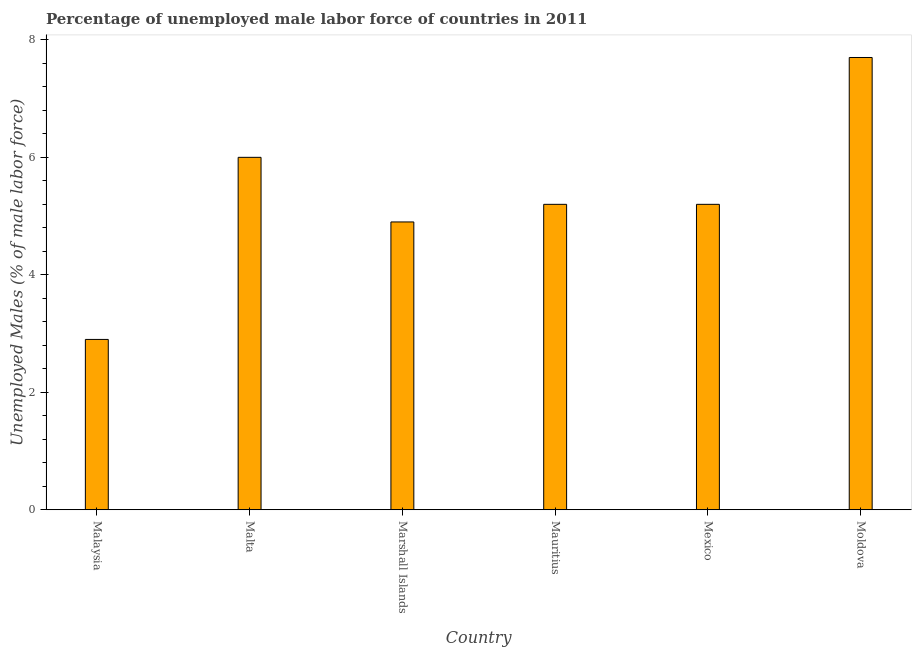Does the graph contain any zero values?
Offer a very short reply. No. What is the title of the graph?
Provide a succinct answer. Percentage of unemployed male labor force of countries in 2011. What is the label or title of the X-axis?
Provide a succinct answer. Country. What is the label or title of the Y-axis?
Offer a very short reply. Unemployed Males (% of male labor force). What is the total unemployed male labour force in Mexico?
Make the answer very short. 5.2. Across all countries, what is the maximum total unemployed male labour force?
Your answer should be very brief. 7.7. Across all countries, what is the minimum total unemployed male labour force?
Give a very brief answer. 2.9. In which country was the total unemployed male labour force maximum?
Offer a terse response. Moldova. In which country was the total unemployed male labour force minimum?
Keep it short and to the point. Malaysia. What is the sum of the total unemployed male labour force?
Offer a very short reply. 31.9. What is the average total unemployed male labour force per country?
Your answer should be compact. 5.32. What is the median total unemployed male labour force?
Keep it short and to the point. 5.2. What is the ratio of the total unemployed male labour force in Mauritius to that in Moldova?
Provide a short and direct response. 0.68. What is the difference between the highest and the lowest total unemployed male labour force?
Provide a short and direct response. 4.8. In how many countries, is the total unemployed male labour force greater than the average total unemployed male labour force taken over all countries?
Your response must be concise. 2. Are the values on the major ticks of Y-axis written in scientific E-notation?
Give a very brief answer. No. What is the Unemployed Males (% of male labor force) of Malaysia?
Give a very brief answer. 2.9. What is the Unemployed Males (% of male labor force) in Malta?
Make the answer very short. 6. What is the Unemployed Males (% of male labor force) in Marshall Islands?
Your response must be concise. 4.9. What is the Unemployed Males (% of male labor force) in Mauritius?
Give a very brief answer. 5.2. What is the Unemployed Males (% of male labor force) in Mexico?
Give a very brief answer. 5.2. What is the Unemployed Males (% of male labor force) in Moldova?
Ensure brevity in your answer.  7.7. What is the difference between the Unemployed Males (% of male labor force) in Malaysia and Malta?
Your answer should be very brief. -3.1. What is the difference between the Unemployed Males (% of male labor force) in Malaysia and Marshall Islands?
Make the answer very short. -2. What is the difference between the Unemployed Males (% of male labor force) in Malta and Mexico?
Ensure brevity in your answer.  0.8. What is the difference between the Unemployed Males (% of male labor force) in Malta and Moldova?
Your answer should be very brief. -1.7. What is the difference between the Unemployed Males (% of male labor force) in Marshall Islands and Mexico?
Make the answer very short. -0.3. What is the ratio of the Unemployed Males (% of male labor force) in Malaysia to that in Malta?
Make the answer very short. 0.48. What is the ratio of the Unemployed Males (% of male labor force) in Malaysia to that in Marshall Islands?
Your answer should be very brief. 0.59. What is the ratio of the Unemployed Males (% of male labor force) in Malaysia to that in Mauritius?
Keep it short and to the point. 0.56. What is the ratio of the Unemployed Males (% of male labor force) in Malaysia to that in Mexico?
Your answer should be compact. 0.56. What is the ratio of the Unemployed Males (% of male labor force) in Malaysia to that in Moldova?
Your answer should be compact. 0.38. What is the ratio of the Unemployed Males (% of male labor force) in Malta to that in Marshall Islands?
Your answer should be compact. 1.22. What is the ratio of the Unemployed Males (% of male labor force) in Malta to that in Mauritius?
Make the answer very short. 1.15. What is the ratio of the Unemployed Males (% of male labor force) in Malta to that in Mexico?
Your answer should be compact. 1.15. What is the ratio of the Unemployed Males (% of male labor force) in Malta to that in Moldova?
Your answer should be compact. 0.78. What is the ratio of the Unemployed Males (% of male labor force) in Marshall Islands to that in Mauritius?
Make the answer very short. 0.94. What is the ratio of the Unemployed Males (% of male labor force) in Marshall Islands to that in Mexico?
Make the answer very short. 0.94. What is the ratio of the Unemployed Males (% of male labor force) in Marshall Islands to that in Moldova?
Provide a short and direct response. 0.64. What is the ratio of the Unemployed Males (% of male labor force) in Mauritius to that in Moldova?
Keep it short and to the point. 0.68. What is the ratio of the Unemployed Males (% of male labor force) in Mexico to that in Moldova?
Your answer should be compact. 0.68. 